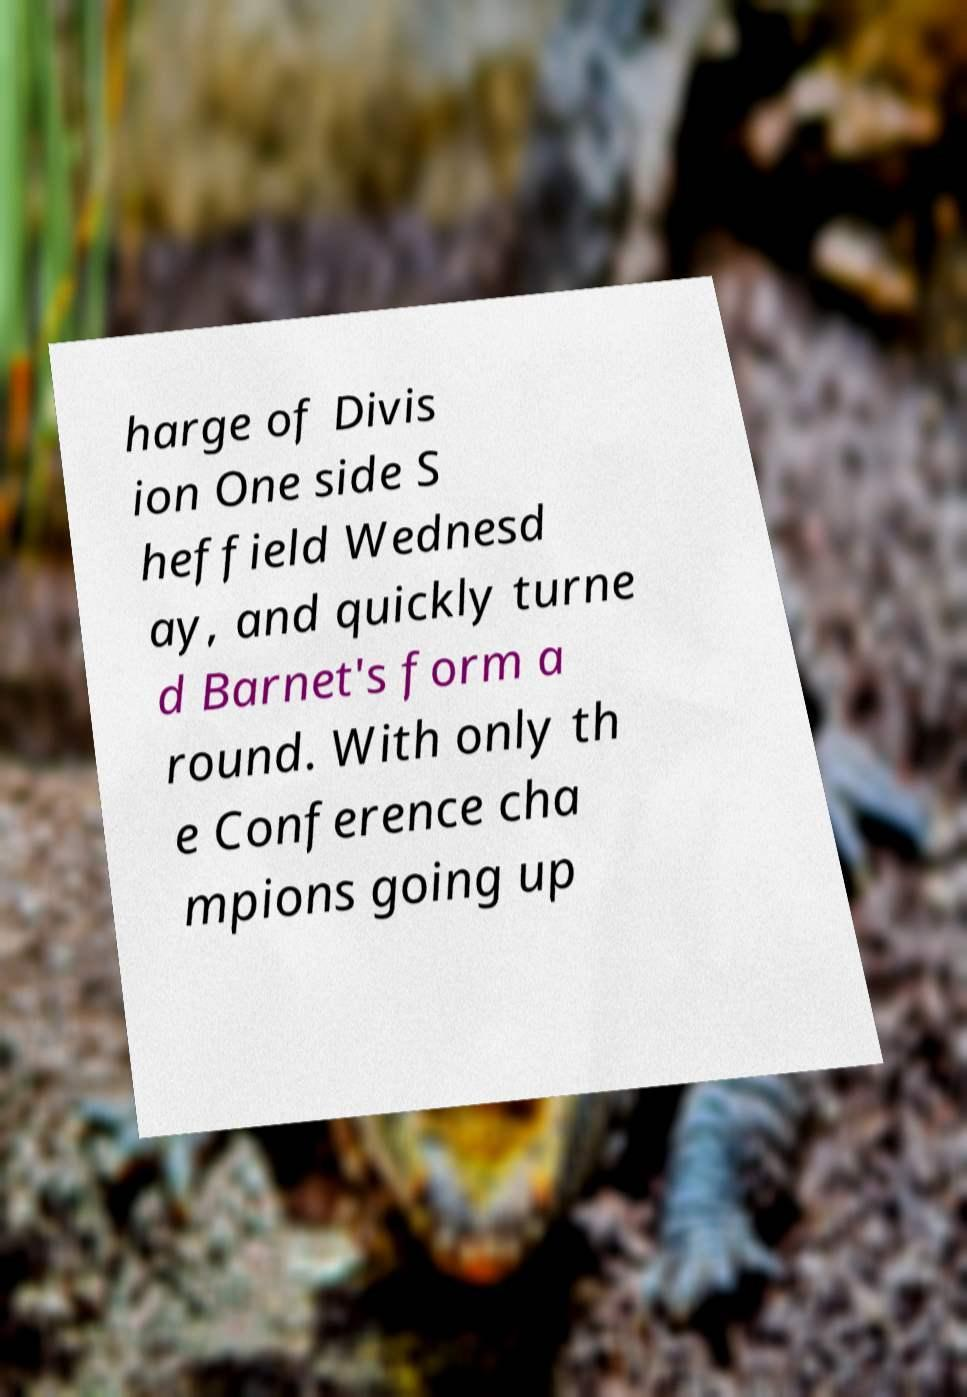Please identify and transcribe the text found in this image. harge of Divis ion One side S heffield Wednesd ay, and quickly turne d Barnet's form a round. With only th e Conference cha mpions going up 